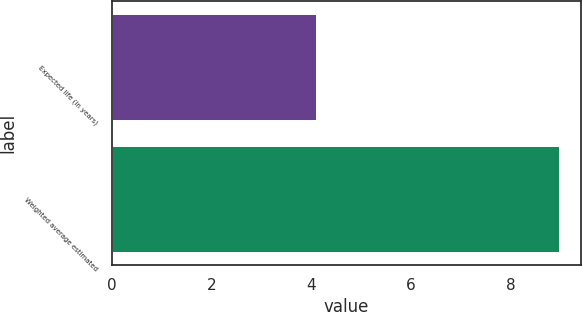<chart> <loc_0><loc_0><loc_500><loc_500><bar_chart><fcel>Expected life (in years)<fcel>Weighted average estimated<nl><fcel>4.1<fcel>8.97<nl></chart> 